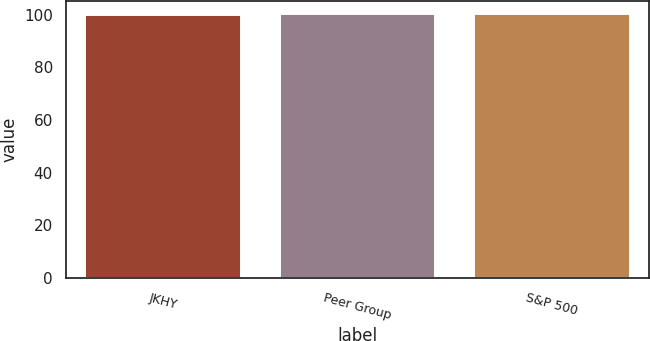<chart> <loc_0><loc_0><loc_500><loc_500><bar_chart><fcel>JKHY<fcel>Peer Group<fcel>S&P 500<nl><fcel>100<fcel>100.1<fcel>100.2<nl></chart> 